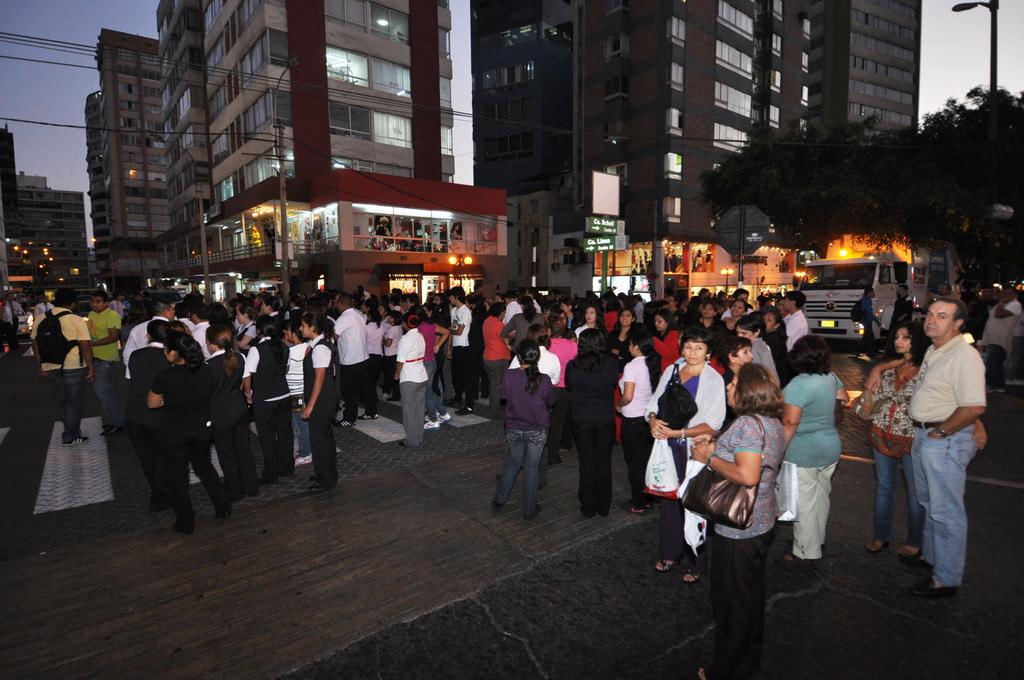What is happening in the image? There are many people standing on the road in the image. What can be seen in the background of the image? There are buildings in the background of the image. What type of vegetation is on the right side of the image? Trees are present on the right side of the image. What is visible above the image? The sky is visible above the image. What rule is being enforced by the wing of the bird in the image? There is no bird or wing present in the image, so no rule is being enforced. 